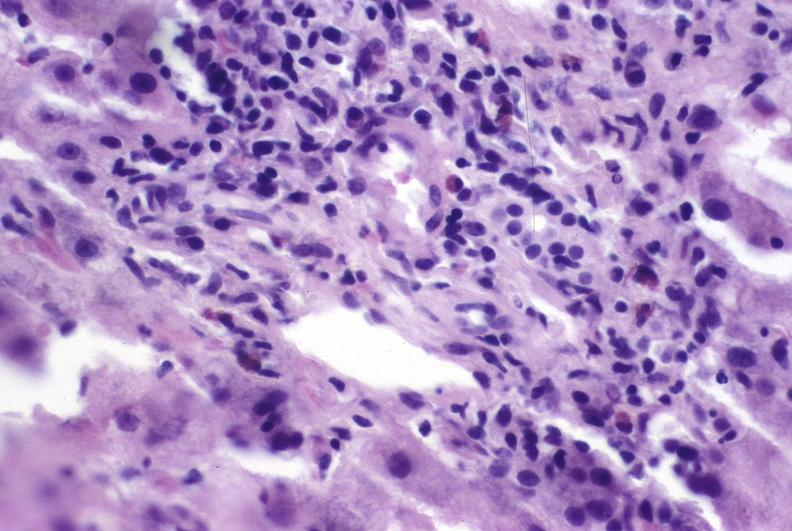what is present?
Answer the question using a single word or phrase. Hepatobiliary 